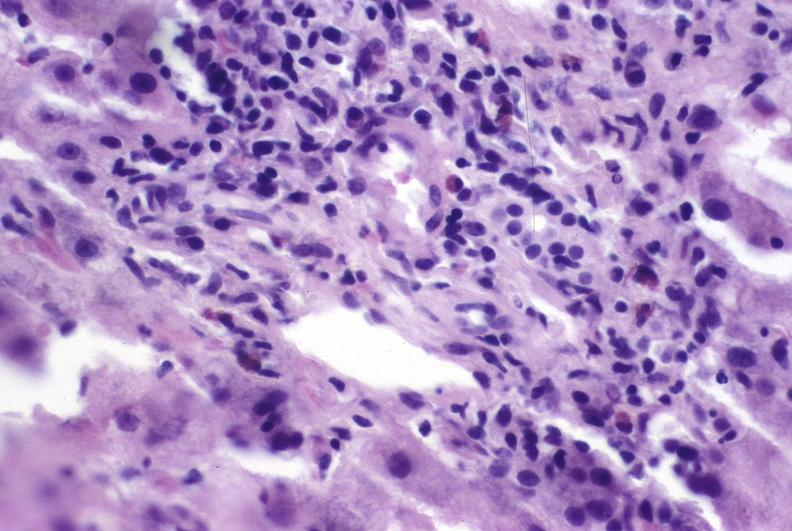what is present?
Answer the question using a single word or phrase. Hepatobiliary 